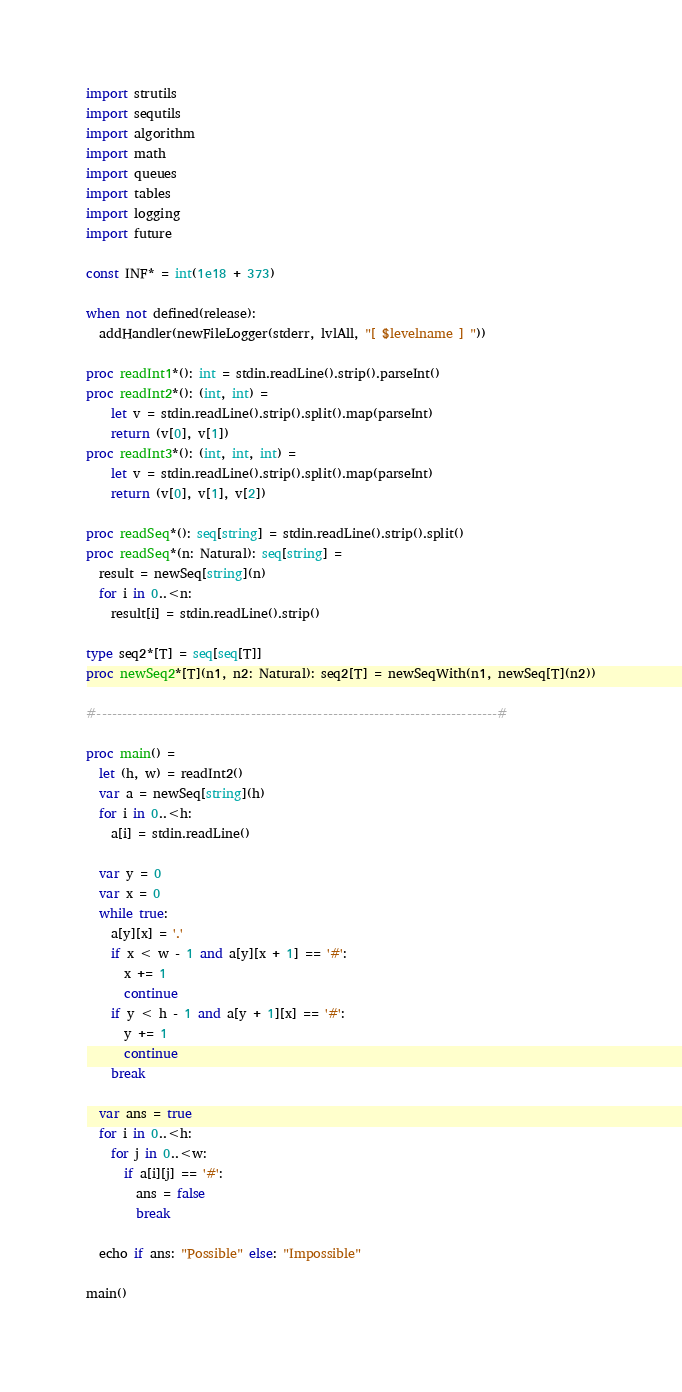<code> <loc_0><loc_0><loc_500><loc_500><_Nim_>import strutils
import sequtils
import algorithm
import math
import queues
import tables
import logging
import future

const INF* = int(1e18 + 373)

when not defined(release):
  addHandler(newFileLogger(stderr, lvlAll, "[ $levelname ] "))

proc readInt1*(): int = stdin.readLine().strip().parseInt()
proc readInt2*(): (int, int) =
    let v = stdin.readLine().strip().split().map(parseInt)
    return (v[0], v[1])
proc readInt3*(): (int, int, int) =
    let v = stdin.readLine().strip().split().map(parseInt)
    return (v[0], v[1], v[2])

proc readSeq*(): seq[string] = stdin.readLine().strip().split()
proc readSeq*(n: Natural): seq[string] =
  result = newSeq[string](n)
  for i in 0..<n:
    result[i] = stdin.readLine().strip()

type seq2*[T] = seq[seq[T]]
proc newSeq2*[T](n1, n2: Natural): seq2[T] = newSeqWith(n1, newSeq[T](n2))

#------------------------------------------------------------------------------#

proc main() =
  let (h, w) = readInt2()
  var a = newSeq[string](h)
  for i in 0..<h:
    a[i] = stdin.readLine()

  var y = 0
  var x = 0
  while true:
    a[y][x] = '.'
    if x < w - 1 and a[y][x + 1] == '#':
      x += 1
      continue
    if y < h - 1 and a[y + 1][x] == '#':
      y += 1
      continue
    break

  var ans = true
  for i in 0..<h:
    for j in 0..<w:
      if a[i][j] == '#':
        ans = false
        break

  echo if ans: "Possible" else: "Impossible"

main()

</code> 